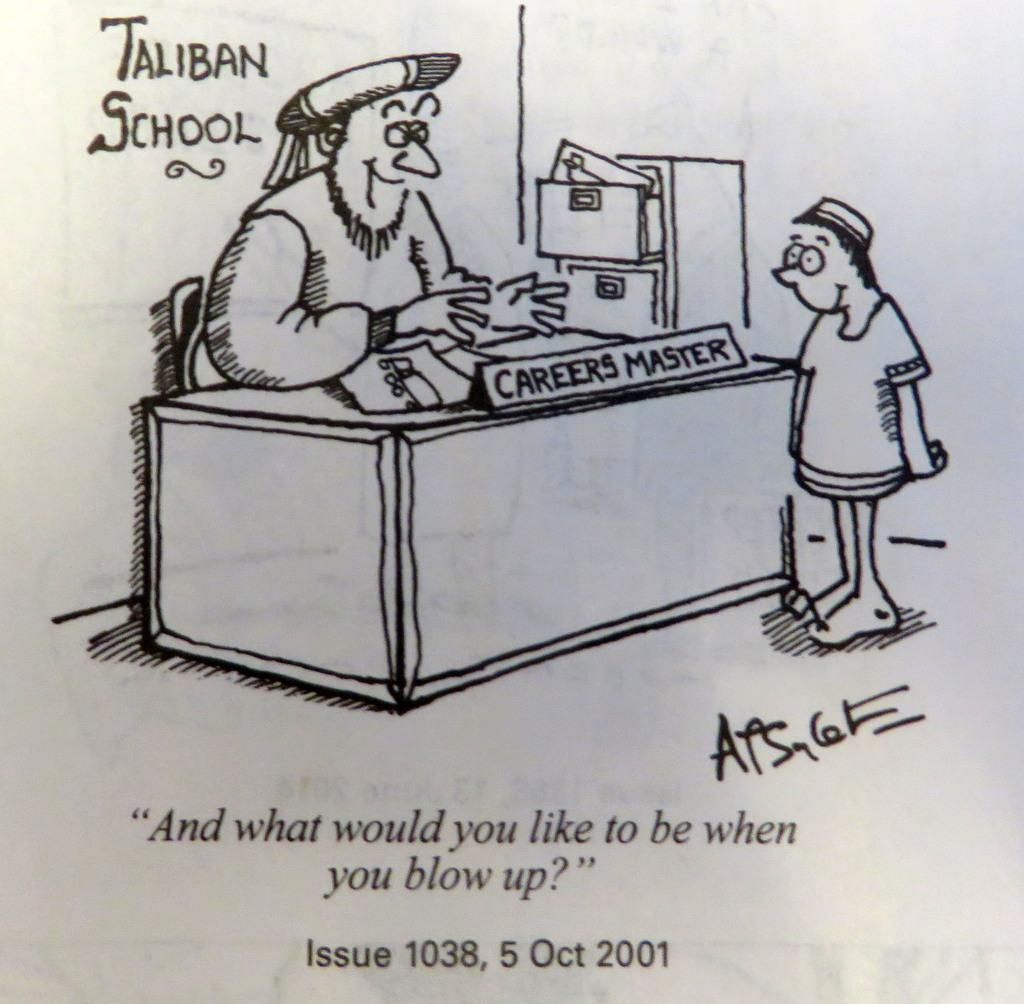What type of visual is the image? The image is a poster. What is the man in the poster doing? The man is sitting on a chair in the poster. What is on the table in the poster? There is a table with papers and a name board in the poster. Who is the person standing in the poster? The person standing in the poster is not identified by name or role. What furniture is present in the poster? There are drawers in the poster. What additional information is provided in the poster? There is some text in the poster. How does the poster compare to the rain in the image? There is no rain present in the image; it is a poster featuring a man sitting on a chair, a table with papers and a name board, a person standing, drawers, and some text. 